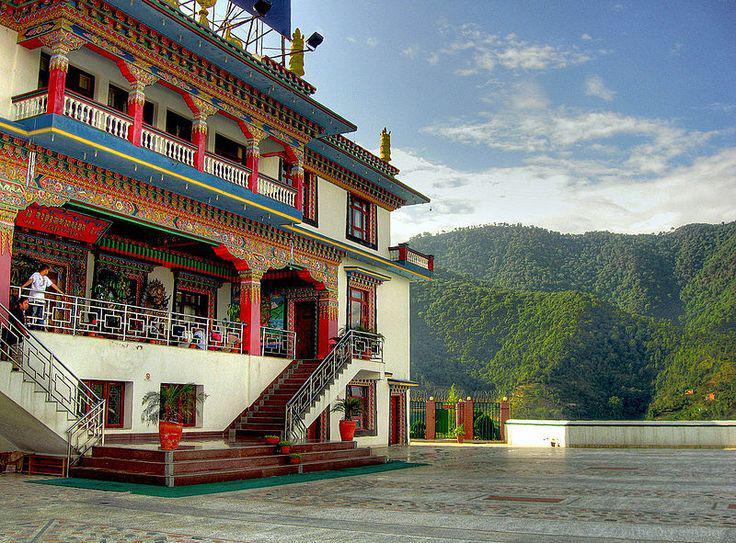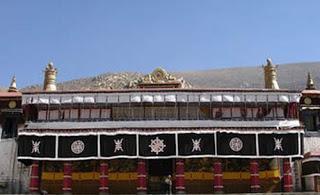The first image is the image on the left, the second image is the image on the right. Assess this claim about the two images: "Left image includes a steep foliage-covered slope and a blue cloud-scattered sky in the scene with a building led to by a stairway.". Correct or not? Answer yes or no. Yes. 